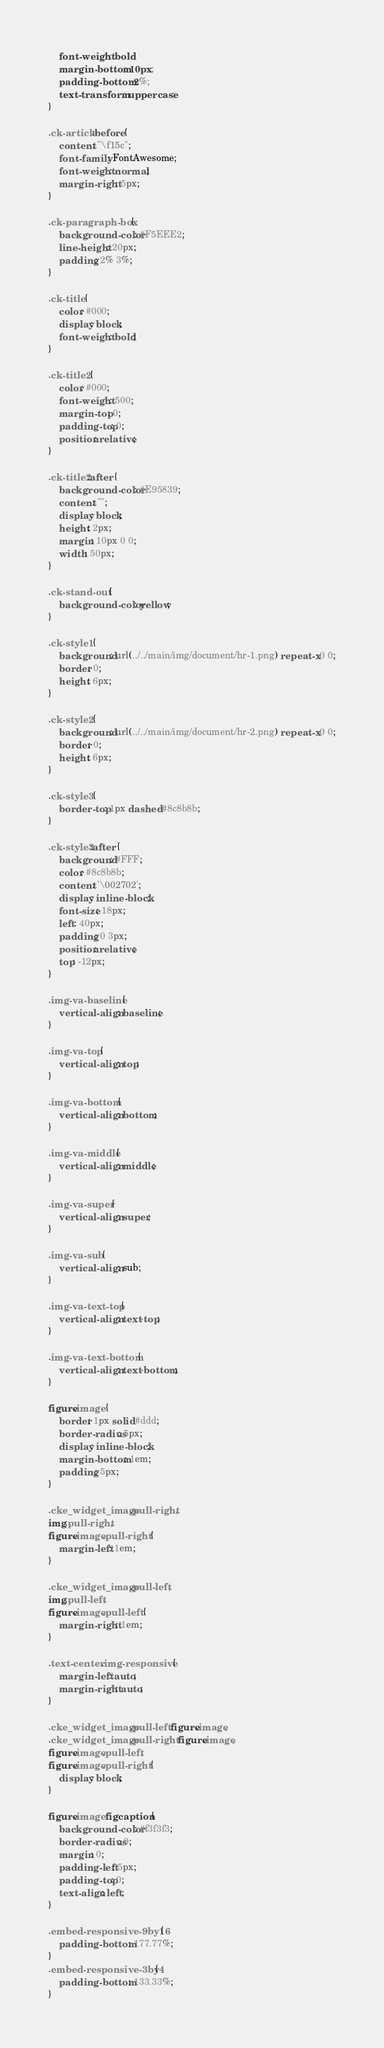Convert code to text. <code><loc_0><loc_0><loc_500><loc_500><_CSS_>    font-weight: bold;
    margin-bottom: 10px;
    padding-bottom: 2%;
    text-transform: uppercase;
}

.ck-article:before {
    content: "\f15c";
    font-family: FontAwesome;
    font-weight: normal;
    margin-right: 5px;
}

.ck-paragraph-box {
    background-color: #F5EEE2;
    line-height: 20px;
    padding: 2% 3%;
}

.ck-title {
    color: #000;
    display: block;
    font-weight: bold;
}

.ck-title2 {
    color: #000;
    font-weight: 500;
    margin-top: 0;
    padding-top: 0;
    position: relative;
}

.ck-title2:after {
    background-color: #E95839;
    content: "";
    display: block;
    height: 2px;
    margin: 10px 0 0;
    width: 50px;
}

.ck-stand-out {
    background-color: yellow;
}

.ck-style1 {
    background: url(../../main/img/document/hr-1.png) repeat-x 0 0;
    border: 0;
    height: 6px;
}

.ck-style2 {
    background: url(../../main/img/document/hr-2.png) repeat-x 0 0;
    border: 0;
    height: 6px;
}

.ck-style3 {
    border-top: 1px dashed #8c8b8b;
}

.ck-style3:after {
    background: #FFF;
    color: #8c8b8b;
    content: '\002702';
    display: inline-block;
    font-size: 18px;
    left: 40px;
    padding: 0 3px;
    position: relative;
    top: -12px;
}

.img-va-baseline {
    vertical-align: baseline;
}

.img-va-top {
    vertical-align: top;
}

.img-va-bottom {
    vertical-align: bottom;
}

.img-va-middle {
    vertical-align: middle;
}

.img-va-super {
    vertical-align: super;
}

.img-va-sub {
    vertical-align: sub;
}

.img-va-text-top {
    vertical-align: text-top;
}

.img-va-text-bottom {
    vertical-align: text-bottom;
}

figure.image {
    border: 1px solid #ddd;
    border-radius: 5px;
    display: inline-block;
    margin-bottom: 1em;
    padding: 5px;
}

.cke_widget_image.pull-right,
img.pull-right,
figure.image.pull-right {
    margin-left: 1em;
}

.cke_widget_image.pull-left,
img.pull-left,
figure.image.pull-left {
    margin-right: 1em;
}

.text-center .img-responsive {
    margin-left: auto;
    margin-right: auto;
}

.cke_widget_image.pull-left figure.image,
.cke_widget_image.pull-right figure.image,
figure.image.pull-left,
figure.image.pull-right {
    display: block;
}

figure.image figcaption {
    background-color: #f3f3f3;
    border-radius: 0;
    margin: 0;
    padding-left: 5px;
    padding-top: 0;
    text-align: left;
}

.embed-responsive-9by16 {
    padding-bottom: 177.77%;
}
.embed-responsive-3by4 {
    padding-bottom: 133.33%;
}
</code> 